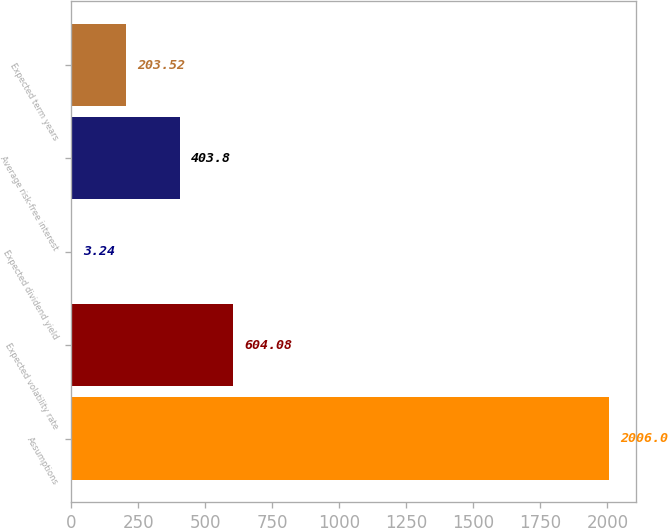Convert chart to OTSL. <chart><loc_0><loc_0><loc_500><loc_500><bar_chart><fcel>Assumptions<fcel>Expected volatility rate<fcel>Expected dividend yield<fcel>Average risk-free interest<fcel>Expected term years<nl><fcel>2006<fcel>604.08<fcel>3.24<fcel>403.8<fcel>203.52<nl></chart> 